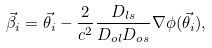Convert formula to latex. <formula><loc_0><loc_0><loc_500><loc_500>\vec { \beta } _ { i } = \vec { \theta _ { i } } - \frac { 2 } { c ^ { 2 } } \frac { D _ { l s } } { D _ { o l } D _ { o s } } \nabla \phi ( \vec { \theta _ { i } } ) ,</formula> 